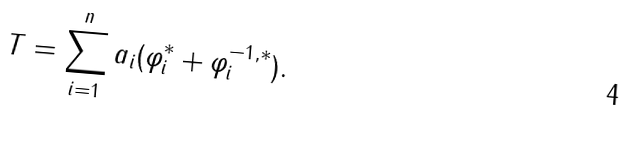<formula> <loc_0><loc_0><loc_500><loc_500>T = \sum _ { i = 1 } ^ { n } a _ { i } ( \varphi _ { i } ^ { \ast } + \varphi _ { i } ^ { - 1 , \ast } ) .</formula> 